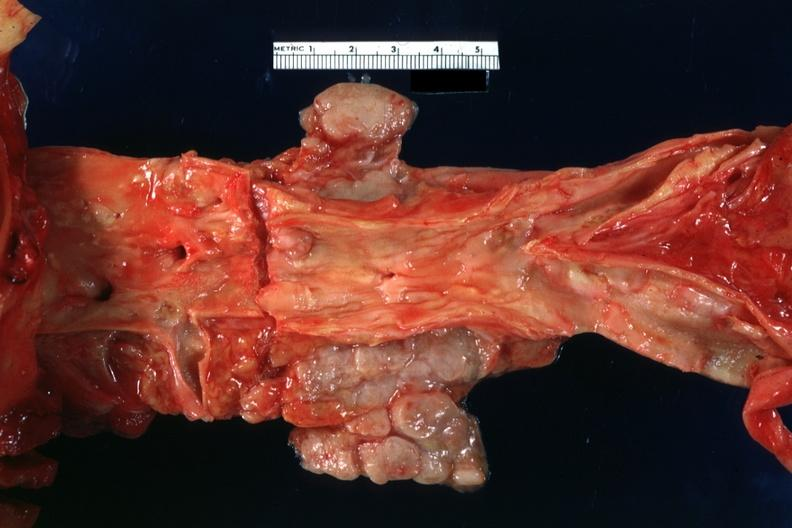does external view of gland with knife cuts into parenchyma hemorrhage show good atherosclerotic plaques?
Answer the question using a single word or phrase. No 